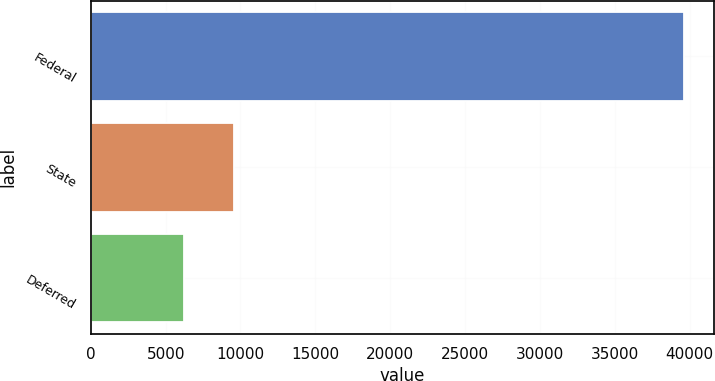Convert chart to OTSL. <chart><loc_0><loc_0><loc_500><loc_500><bar_chart><fcel>Federal<fcel>State<fcel>Deferred<nl><fcel>39624<fcel>9569.4<fcel>6230<nl></chart> 